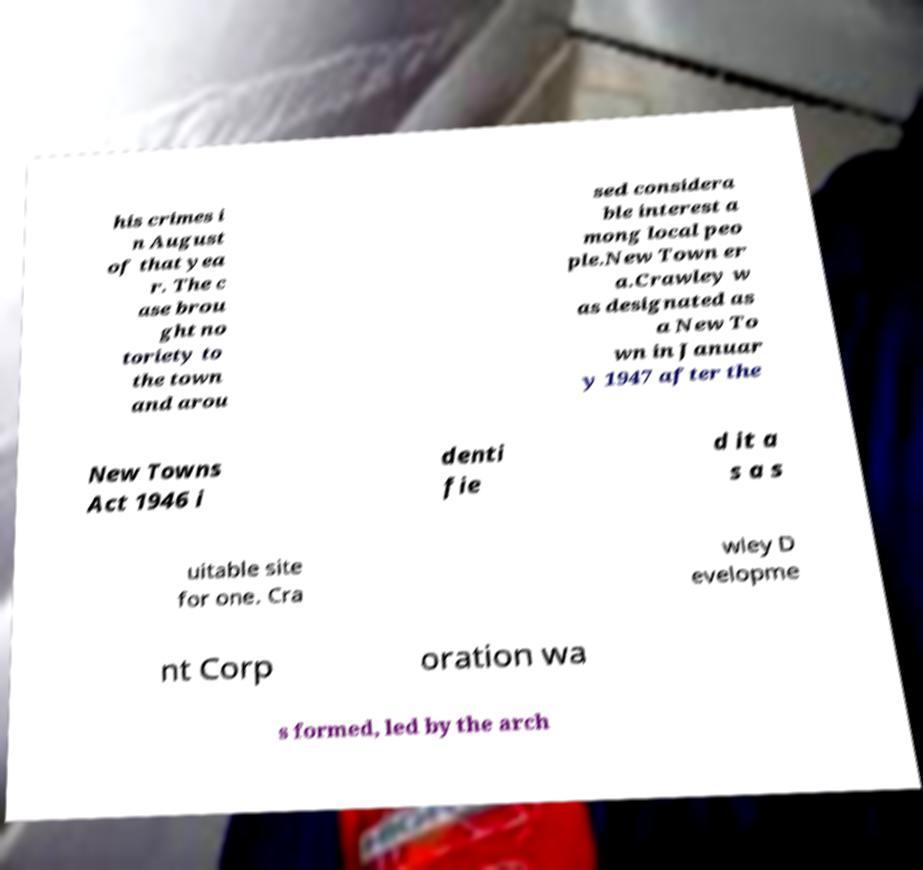What messages or text are displayed in this image? I need them in a readable, typed format. his crimes i n August of that yea r. The c ase brou ght no toriety to the town and arou sed considera ble interest a mong local peo ple.New Town er a.Crawley w as designated as a New To wn in Januar y 1947 after the New Towns Act 1946 i denti fie d it a s a s uitable site for one. Cra wley D evelopme nt Corp oration wa s formed, led by the arch 